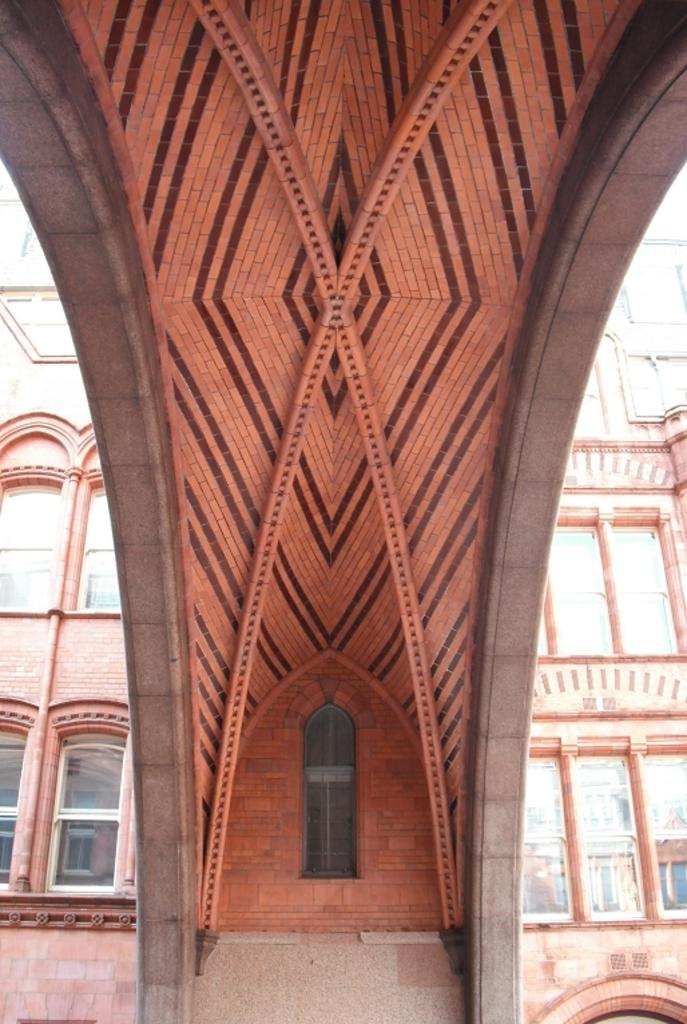What type of structure is present in the image? There is a building in the image. What feature can be observed on the building? The building has glass windows. How many pigs are visible inside the building in the image? There are no pigs visible inside the building in the image. What type of ink is used to write on the glass windows of the building? There is no indication of any writing or ink on the glass windows of the building in the image. 